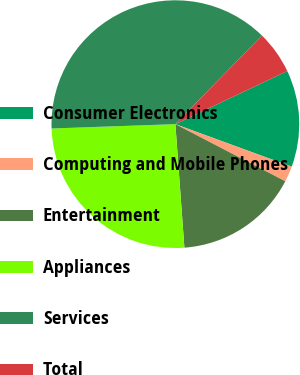Convert chart. <chart><loc_0><loc_0><loc_500><loc_500><pie_chart><fcel>Consumer Electronics<fcel>Computing and Mobile Phones<fcel>Entertainment<fcel>Appliances<fcel>Services<fcel>Total<nl><fcel>12.63%<fcel>2.05%<fcel>16.21%<fcel>25.6%<fcel>37.88%<fcel>5.63%<nl></chart> 